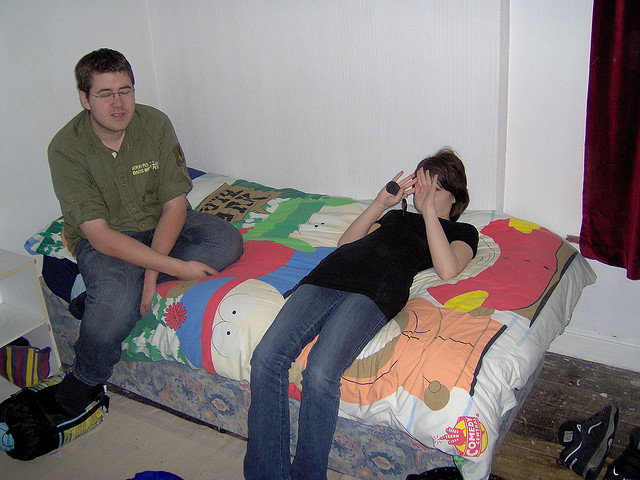<image>What two letters on are on his shirt? I am not sure what two letters are on his shirt, it could be 'ts', 'ad', 'and d', 'and e', 'sp', 'da', 'ae', 'on', or 'gs'. What two letters on are on his shirt? I am not sure which two letters are on his shirt. It could be 'ts', 'ad', or 'and d'. 